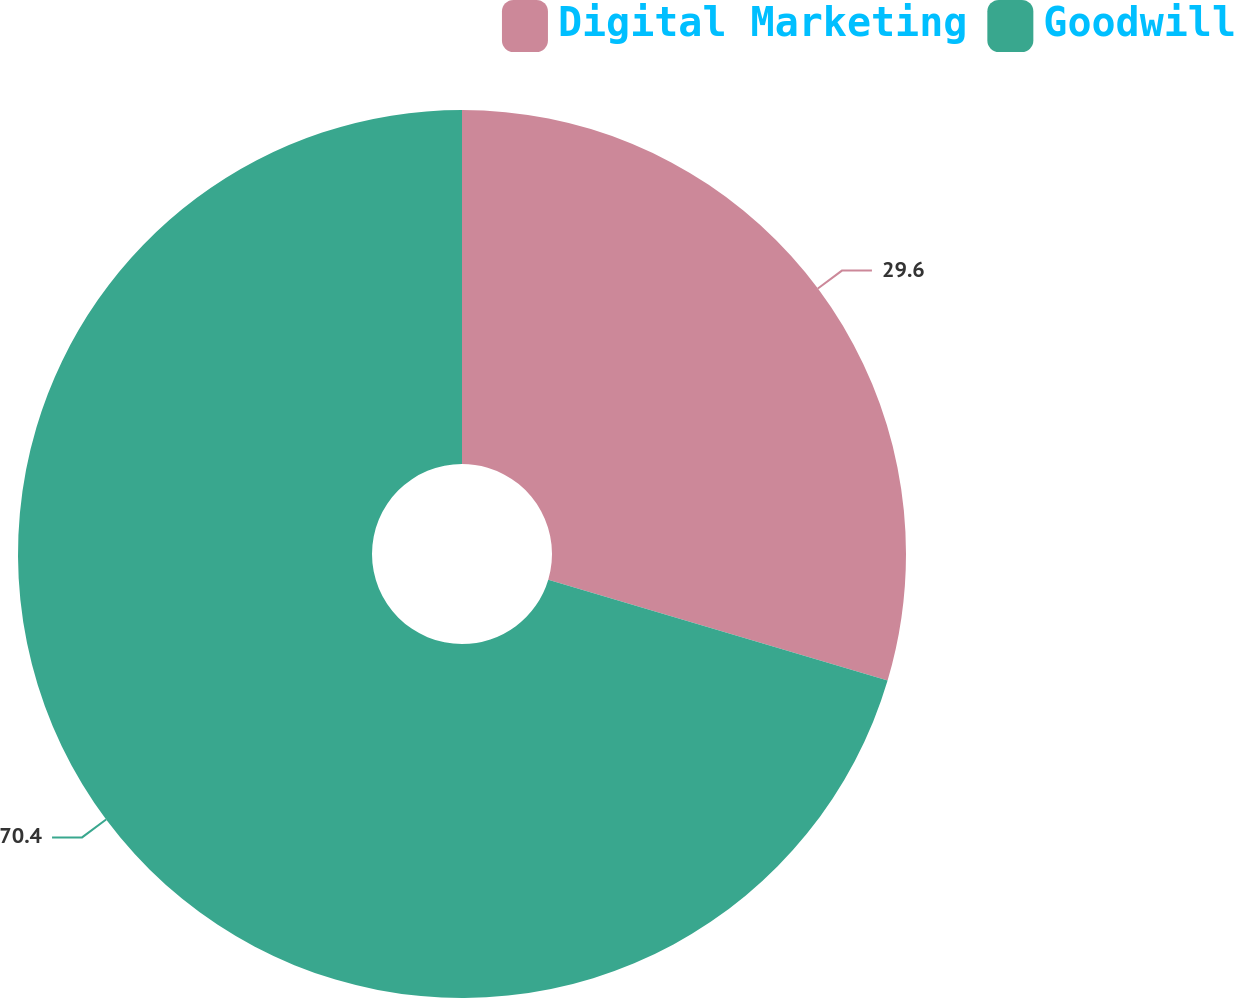Convert chart. <chart><loc_0><loc_0><loc_500><loc_500><pie_chart><fcel>Digital Marketing<fcel>Goodwill<nl><fcel>29.6%<fcel>70.4%<nl></chart> 